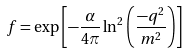Convert formula to latex. <formula><loc_0><loc_0><loc_500><loc_500>f = \exp \left [ - \frac { \alpha } { 4 \pi } \ln ^ { 2 } \left ( \frac { - q ^ { 2 } } { m ^ { 2 } } \right ) \right ]</formula> 